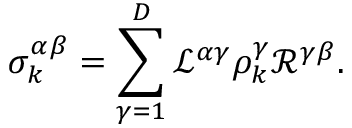<formula> <loc_0><loc_0><loc_500><loc_500>\sigma _ { k } ^ { \alpha \beta } = \sum _ { \gamma = 1 } ^ { D } \mathcal { L } ^ { \alpha \gamma } \rho _ { k } ^ { \gamma } \mathcal { R } ^ { \gamma \beta } .</formula> 